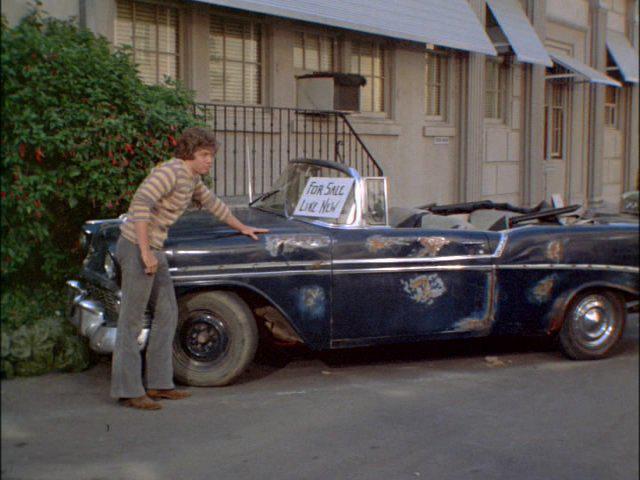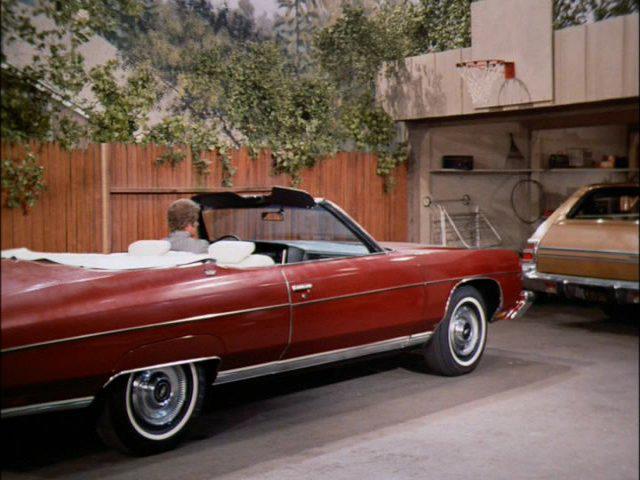The first image is the image on the left, the second image is the image on the right. Analyze the images presented: Is the assertion "A human is standing in front of a car in one photo." valid? Answer yes or no. Yes. The first image is the image on the left, the second image is the image on the right. Analyze the images presented: Is the assertion "An image shows a young male standing at the front of a beat-up looking convertible." valid? Answer yes or no. Yes. 